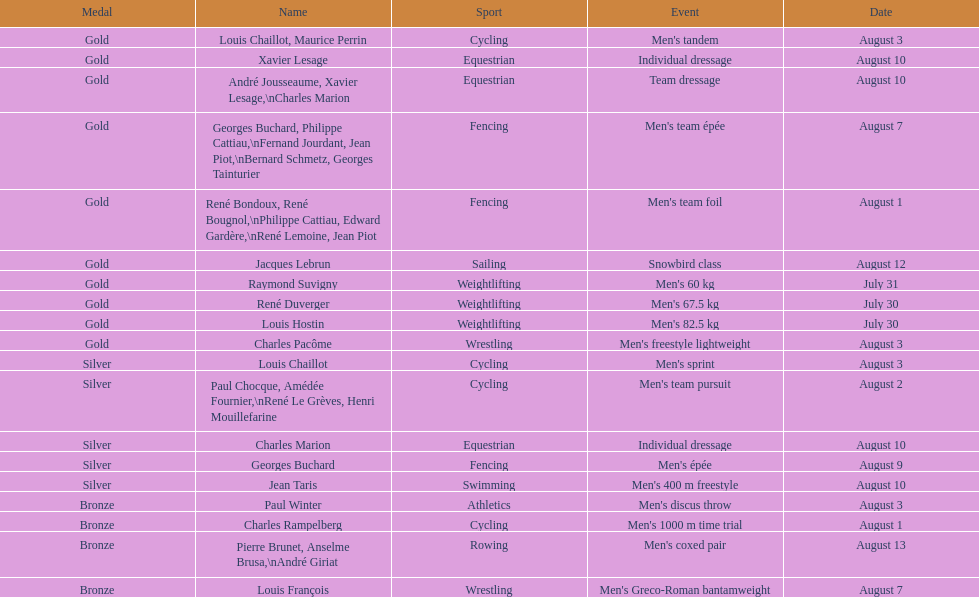How many medals were obtained after august 3? 9. 